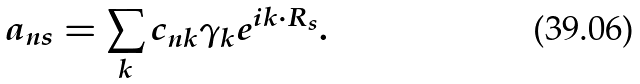Convert formula to latex. <formula><loc_0><loc_0><loc_500><loc_500>a _ { n s } = \sum _ { k } c _ { n { k } } \gamma _ { k } e ^ { i { k } \cdot { R } _ { s } } .</formula> 